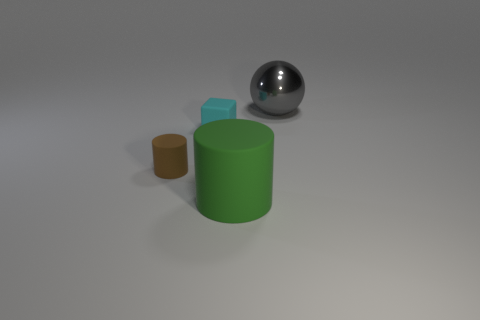Add 1 tiny cubes. How many objects exist? 5 Subtract 0 purple balls. How many objects are left? 4 Subtract all balls. How many objects are left? 3 Subtract 1 cubes. How many cubes are left? 0 Subtract all yellow balls. Subtract all blue blocks. How many balls are left? 1 Subtract all yellow blocks. How many brown cylinders are left? 1 Subtract all big yellow rubber balls. Subtract all big green cylinders. How many objects are left? 3 Add 3 small cyan blocks. How many small cyan blocks are left? 4 Add 1 cyan blocks. How many cyan blocks exist? 2 Subtract all green cylinders. How many cylinders are left? 1 